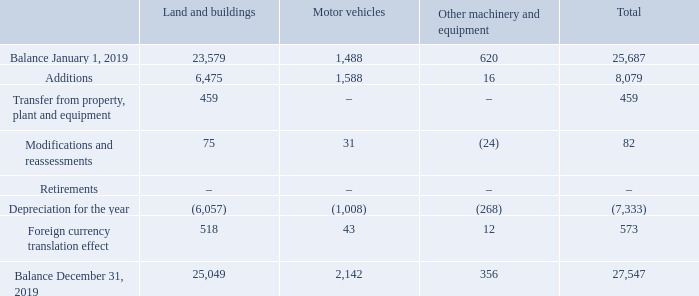NOTE 2. RIGHT-OF-USE ASSETS
The Company leases many assets, including land, buildings, houses, motor vehicles, machinery and equipment. Leases typically run up to a period of 5 years, some with an option to renew the lease after the end of the non-cancelable period. Lease payments are renegotiated on a periodic basis; timing is depending on the region and type of lease. The Company has not entered into any sub-lease arrangements.
Right-of-use assets
What is the lease duration for the company? Typically run up to a period of 5 years. What are the types of assets included in the table? Land and buildings, motor vehicles, other machinery and equipment. What is the total balance in january 1, 2019? 25,687. Which type of asset had the greatest depreciation for the year? For COL 3-5, row 7, find the largest number and the corresponding asset
Answer: land and buildings. What is the average depreciation for the year for the assets? -7,333/3
Answer: -2444.33. What is the change in total Balance from January 1, 2019 to December 31, 2019   27,547 - 25,687 
Answer: 1860. 